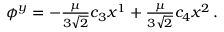Convert formula to latex. <formula><loc_0><loc_0><loc_500><loc_500>\phi ^ { y } = - \frac { \mu } { 3 \sqrt { 2 } } c _ { 3 } x ^ { 1 } + \frac { \mu } { 3 \sqrt { 2 } } c _ { 4 } x ^ { 2 } \, .</formula> 